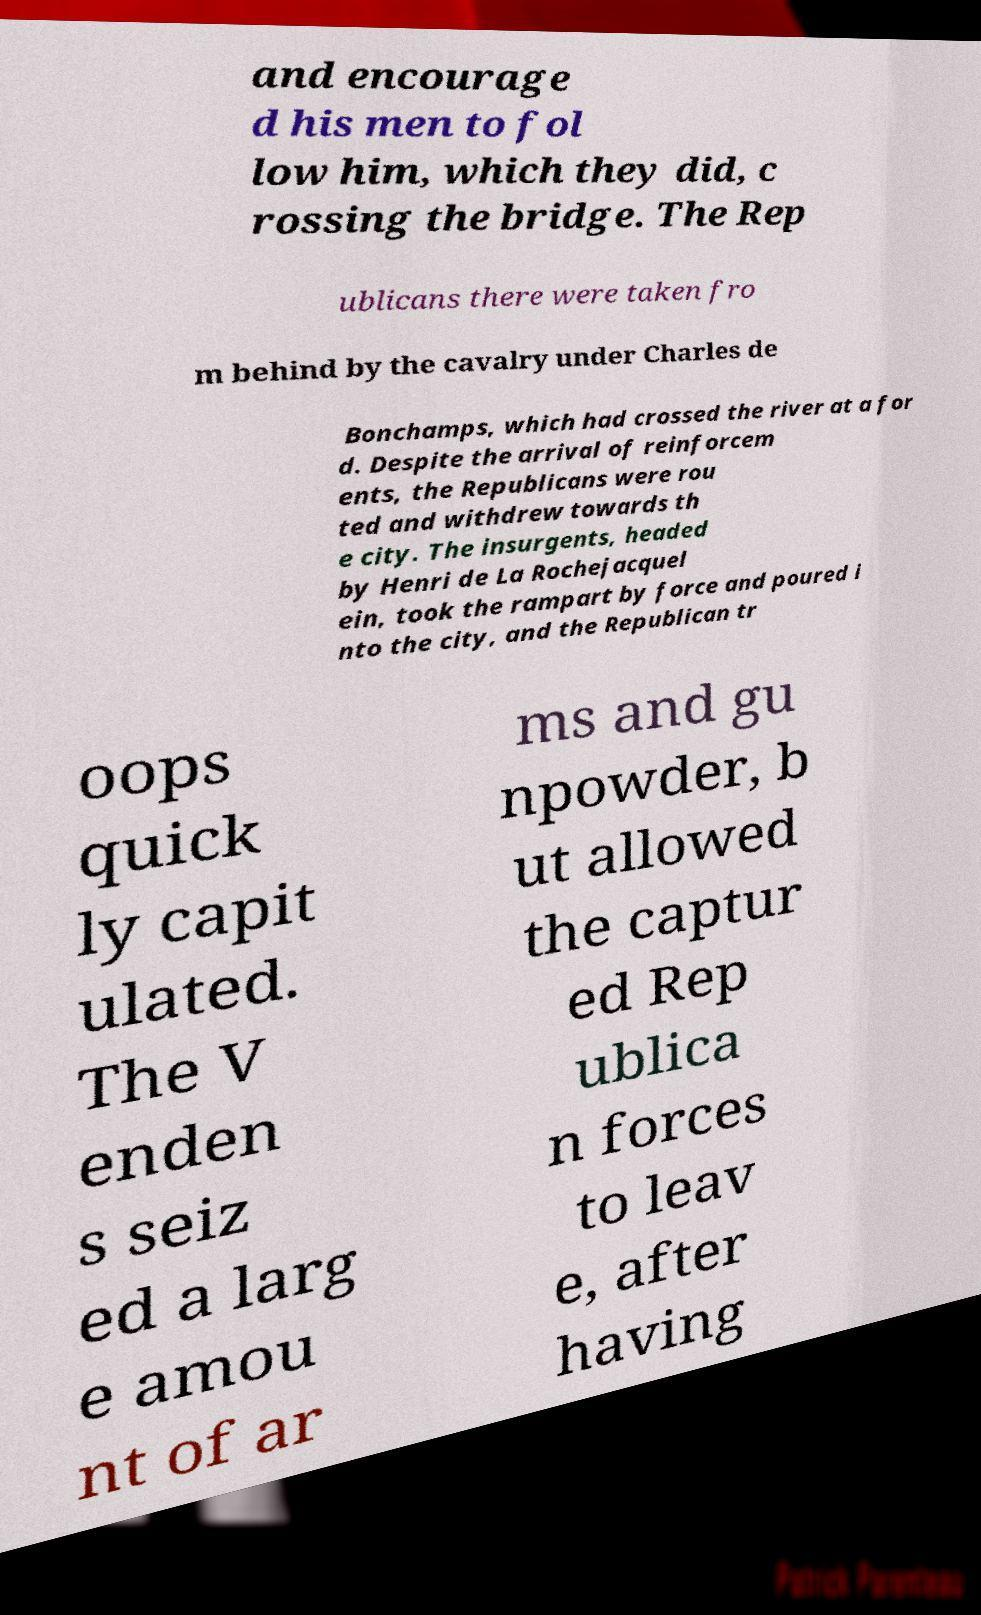What messages or text are displayed in this image? I need them in a readable, typed format. and encourage d his men to fol low him, which they did, c rossing the bridge. The Rep ublicans there were taken fro m behind by the cavalry under Charles de Bonchamps, which had crossed the river at a for d. Despite the arrival of reinforcem ents, the Republicans were rou ted and withdrew towards th e city. The insurgents, headed by Henri de La Rochejacquel ein, took the rampart by force and poured i nto the city, and the Republican tr oops quick ly capit ulated. The V enden s seiz ed a larg e amou nt of ar ms and gu npowder, b ut allowed the captur ed Rep ublica n forces to leav e, after having 